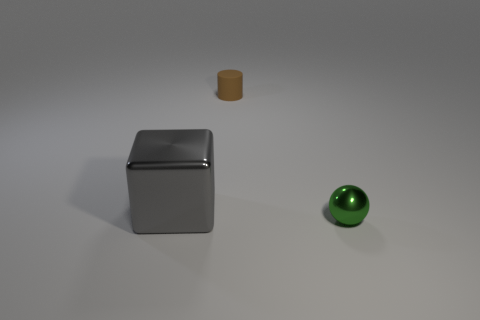Add 3 red cylinders. How many objects exist? 6 Subtract all balls. How many objects are left? 2 Add 2 purple metallic cylinders. How many purple metallic cylinders exist? 2 Subtract 0 purple blocks. How many objects are left? 3 Subtract all large gray shiny objects. Subtract all big cyan shiny cubes. How many objects are left? 2 Add 2 brown matte cylinders. How many brown matte cylinders are left? 3 